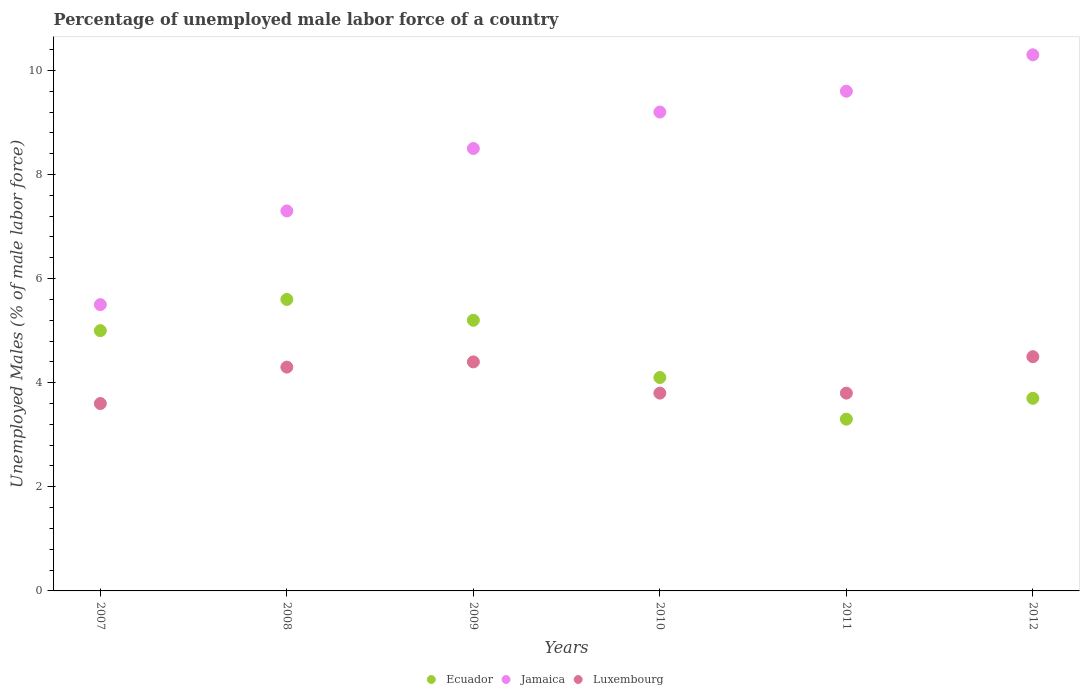Is the number of dotlines equal to the number of legend labels?
Ensure brevity in your answer.  Yes. Across all years, what is the maximum percentage of unemployed male labor force in Luxembourg?
Your answer should be compact. 4.5. Across all years, what is the minimum percentage of unemployed male labor force in Luxembourg?
Make the answer very short. 3.6. In which year was the percentage of unemployed male labor force in Ecuador maximum?
Your answer should be compact. 2008. In which year was the percentage of unemployed male labor force in Ecuador minimum?
Your answer should be compact. 2011. What is the total percentage of unemployed male labor force in Ecuador in the graph?
Your response must be concise. 26.9. What is the difference between the percentage of unemployed male labor force in Jamaica in 2010 and that in 2012?
Offer a terse response. -1.1. What is the difference between the percentage of unemployed male labor force in Jamaica in 2009 and the percentage of unemployed male labor force in Ecuador in 2012?
Make the answer very short. 4.8. What is the average percentage of unemployed male labor force in Ecuador per year?
Provide a succinct answer. 4.48. In the year 2007, what is the difference between the percentage of unemployed male labor force in Luxembourg and percentage of unemployed male labor force in Jamaica?
Your response must be concise. -1.9. What is the ratio of the percentage of unemployed male labor force in Luxembourg in 2007 to that in 2009?
Offer a terse response. 0.82. Is the percentage of unemployed male labor force in Jamaica in 2009 less than that in 2012?
Your response must be concise. Yes. Is the difference between the percentage of unemployed male labor force in Luxembourg in 2008 and 2009 greater than the difference between the percentage of unemployed male labor force in Jamaica in 2008 and 2009?
Your answer should be very brief. Yes. What is the difference between the highest and the second highest percentage of unemployed male labor force in Jamaica?
Make the answer very short. 0.7. What is the difference between the highest and the lowest percentage of unemployed male labor force in Jamaica?
Your answer should be compact. 4.8. Does the percentage of unemployed male labor force in Jamaica monotonically increase over the years?
Make the answer very short. Yes. Is the percentage of unemployed male labor force in Jamaica strictly greater than the percentage of unemployed male labor force in Luxembourg over the years?
Keep it short and to the point. Yes. Is the percentage of unemployed male labor force in Ecuador strictly less than the percentage of unemployed male labor force in Luxembourg over the years?
Your answer should be compact. No. How many dotlines are there?
Provide a short and direct response. 3. How many years are there in the graph?
Your response must be concise. 6. Are the values on the major ticks of Y-axis written in scientific E-notation?
Provide a short and direct response. No. Does the graph contain any zero values?
Your answer should be compact. No. What is the title of the graph?
Make the answer very short. Percentage of unemployed male labor force of a country. What is the label or title of the Y-axis?
Provide a short and direct response. Unemployed Males (% of male labor force). What is the Unemployed Males (% of male labor force) in Luxembourg in 2007?
Your response must be concise. 3.6. What is the Unemployed Males (% of male labor force) in Ecuador in 2008?
Offer a terse response. 5.6. What is the Unemployed Males (% of male labor force) of Jamaica in 2008?
Offer a terse response. 7.3. What is the Unemployed Males (% of male labor force) of Luxembourg in 2008?
Offer a very short reply. 4.3. What is the Unemployed Males (% of male labor force) in Ecuador in 2009?
Ensure brevity in your answer.  5.2. What is the Unemployed Males (% of male labor force) in Luxembourg in 2009?
Give a very brief answer. 4.4. What is the Unemployed Males (% of male labor force) of Ecuador in 2010?
Ensure brevity in your answer.  4.1. What is the Unemployed Males (% of male labor force) in Jamaica in 2010?
Ensure brevity in your answer.  9.2. What is the Unemployed Males (% of male labor force) of Luxembourg in 2010?
Offer a terse response. 3.8. What is the Unemployed Males (% of male labor force) of Ecuador in 2011?
Provide a short and direct response. 3.3. What is the Unemployed Males (% of male labor force) in Jamaica in 2011?
Offer a terse response. 9.6. What is the Unemployed Males (% of male labor force) of Luxembourg in 2011?
Your answer should be very brief. 3.8. What is the Unemployed Males (% of male labor force) in Ecuador in 2012?
Your answer should be compact. 3.7. What is the Unemployed Males (% of male labor force) in Jamaica in 2012?
Keep it short and to the point. 10.3. Across all years, what is the maximum Unemployed Males (% of male labor force) of Ecuador?
Make the answer very short. 5.6. Across all years, what is the maximum Unemployed Males (% of male labor force) of Jamaica?
Your answer should be very brief. 10.3. Across all years, what is the maximum Unemployed Males (% of male labor force) in Luxembourg?
Ensure brevity in your answer.  4.5. Across all years, what is the minimum Unemployed Males (% of male labor force) of Ecuador?
Offer a very short reply. 3.3. Across all years, what is the minimum Unemployed Males (% of male labor force) in Luxembourg?
Provide a short and direct response. 3.6. What is the total Unemployed Males (% of male labor force) of Ecuador in the graph?
Provide a succinct answer. 26.9. What is the total Unemployed Males (% of male labor force) in Jamaica in the graph?
Give a very brief answer. 50.4. What is the total Unemployed Males (% of male labor force) of Luxembourg in the graph?
Your answer should be very brief. 24.4. What is the difference between the Unemployed Males (% of male labor force) in Ecuador in 2007 and that in 2008?
Provide a short and direct response. -0.6. What is the difference between the Unemployed Males (% of male labor force) in Ecuador in 2007 and that in 2009?
Provide a succinct answer. -0.2. What is the difference between the Unemployed Males (% of male labor force) of Jamaica in 2007 and that in 2009?
Your response must be concise. -3. What is the difference between the Unemployed Males (% of male labor force) in Luxembourg in 2007 and that in 2010?
Offer a terse response. -0.2. What is the difference between the Unemployed Males (% of male labor force) of Ecuador in 2007 and that in 2011?
Offer a very short reply. 1.7. What is the difference between the Unemployed Males (% of male labor force) of Jamaica in 2007 and that in 2011?
Keep it short and to the point. -4.1. What is the difference between the Unemployed Males (% of male labor force) of Ecuador in 2007 and that in 2012?
Make the answer very short. 1.3. What is the difference between the Unemployed Males (% of male labor force) of Luxembourg in 2007 and that in 2012?
Make the answer very short. -0.9. What is the difference between the Unemployed Males (% of male labor force) of Ecuador in 2008 and that in 2009?
Offer a terse response. 0.4. What is the difference between the Unemployed Males (% of male labor force) of Jamaica in 2008 and that in 2010?
Offer a very short reply. -1.9. What is the difference between the Unemployed Males (% of male labor force) of Ecuador in 2008 and that in 2011?
Offer a very short reply. 2.3. What is the difference between the Unemployed Males (% of male labor force) in Jamaica in 2008 and that in 2011?
Your answer should be compact. -2.3. What is the difference between the Unemployed Males (% of male labor force) of Luxembourg in 2008 and that in 2011?
Provide a short and direct response. 0.5. What is the difference between the Unemployed Males (% of male labor force) in Jamaica in 2008 and that in 2012?
Your answer should be very brief. -3. What is the difference between the Unemployed Males (% of male labor force) of Luxembourg in 2009 and that in 2010?
Provide a succinct answer. 0.6. What is the difference between the Unemployed Males (% of male labor force) of Ecuador in 2009 and that in 2011?
Provide a succinct answer. 1.9. What is the difference between the Unemployed Males (% of male labor force) in Jamaica in 2009 and that in 2011?
Your answer should be very brief. -1.1. What is the difference between the Unemployed Males (% of male labor force) in Luxembourg in 2009 and that in 2011?
Provide a succinct answer. 0.6. What is the difference between the Unemployed Males (% of male labor force) of Ecuador in 2009 and that in 2012?
Your answer should be compact. 1.5. What is the difference between the Unemployed Males (% of male labor force) in Jamaica in 2009 and that in 2012?
Provide a short and direct response. -1.8. What is the difference between the Unemployed Males (% of male labor force) in Luxembourg in 2009 and that in 2012?
Keep it short and to the point. -0.1. What is the difference between the Unemployed Males (% of male labor force) of Jamaica in 2010 and that in 2011?
Ensure brevity in your answer.  -0.4. What is the difference between the Unemployed Males (% of male labor force) of Luxembourg in 2010 and that in 2011?
Provide a succinct answer. 0. What is the difference between the Unemployed Males (% of male labor force) of Ecuador in 2010 and that in 2012?
Offer a terse response. 0.4. What is the difference between the Unemployed Males (% of male labor force) of Luxembourg in 2010 and that in 2012?
Ensure brevity in your answer.  -0.7. What is the difference between the Unemployed Males (% of male labor force) in Jamaica in 2011 and that in 2012?
Keep it short and to the point. -0.7. What is the difference between the Unemployed Males (% of male labor force) of Jamaica in 2007 and the Unemployed Males (% of male labor force) of Luxembourg in 2009?
Provide a short and direct response. 1.1. What is the difference between the Unemployed Males (% of male labor force) in Ecuador in 2007 and the Unemployed Males (% of male labor force) in Luxembourg in 2010?
Your answer should be compact. 1.2. What is the difference between the Unemployed Males (% of male labor force) of Jamaica in 2007 and the Unemployed Males (% of male labor force) of Luxembourg in 2010?
Your response must be concise. 1.7. What is the difference between the Unemployed Males (% of male labor force) of Ecuador in 2007 and the Unemployed Males (% of male labor force) of Jamaica in 2011?
Provide a succinct answer. -4.6. What is the difference between the Unemployed Males (% of male labor force) in Ecuador in 2007 and the Unemployed Males (% of male labor force) in Jamaica in 2012?
Keep it short and to the point. -5.3. What is the difference between the Unemployed Males (% of male labor force) of Jamaica in 2007 and the Unemployed Males (% of male labor force) of Luxembourg in 2012?
Provide a short and direct response. 1. What is the difference between the Unemployed Males (% of male labor force) in Ecuador in 2008 and the Unemployed Males (% of male labor force) in Jamaica in 2009?
Provide a short and direct response. -2.9. What is the difference between the Unemployed Males (% of male labor force) in Ecuador in 2008 and the Unemployed Males (% of male labor force) in Jamaica in 2010?
Provide a short and direct response. -3.6. What is the difference between the Unemployed Males (% of male labor force) in Ecuador in 2008 and the Unemployed Males (% of male labor force) in Luxembourg in 2010?
Ensure brevity in your answer.  1.8. What is the difference between the Unemployed Males (% of male labor force) of Jamaica in 2008 and the Unemployed Males (% of male labor force) of Luxembourg in 2010?
Provide a succinct answer. 3.5. What is the difference between the Unemployed Males (% of male labor force) of Jamaica in 2008 and the Unemployed Males (% of male labor force) of Luxembourg in 2011?
Provide a succinct answer. 3.5. What is the difference between the Unemployed Males (% of male labor force) in Ecuador in 2008 and the Unemployed Males (% of male labor force) in Jamaica in 2012?
Keep it short and to the point. -4.7. What is the difference between the Unemployed Males (% of male labor force) in Jamaica in 2008 and the Unemployed Males (% of male labor force) in Luxembourg in 2012?
Keep it short and to the point. 2.8. What is the difference between the Unemployed Males (% of male labor force) in Ecuador in 2009 and the Unemployed Males (% of male labor force) in Jamaica in 2010?
Offer a very short reply. -4. What is the difference between the Unemployed Males (% of male labor force) of Ecuador in 2009 and the Unemployed Males (% of male labor force) of Luxembourg in 2010?
Your answer should be compact. 1.4. What is the difference between the Unemployed Males (% of male labor force) of Ecuador in 2009 and the Unemployed Males (% of male labor force) of Luxembourg in 2011?
Your answer should be compact. 1.4. What is the difference between the Unemployed Males (% of male labor force) of Jamaica in 2009 and the Unemployed Males (% of male labor force) of Luxembourg in 2011?
Make the answer very short. 4.7. What is the difference between the Unemployed Males (% of male labor force) in Ecuador in 2009 and the Unemployed Males (% of male labor force) in Jamaica in 2012?
Provide a succinct answer. -5.1. What is the difference between the Unemployed Males (% of male labor force) of Ecuador in 2009 and the Unemployed Males (% of male labor force) of Luxembourg in 2012?
Give a very brief answer. 0.7. What is the difference between the Unemployed Males (% of male labor force) in Ecuador in 2010 and the Unemployed Males (% of male labor force) in Luxembourg in 2011?
Offer a very short reply. 0.3. What is the difference between the Unemployed Males (% of male labor force) of Jamaica in 2010 and the Unemployed Males (% of male labor force) of Luxembourg in 2011?
Provide a succinct answer. 5.4. What is the difference between the Unemployed Males (% of male labor force) in Ecuador in 2010 and the Unemployed Males (% of male labor force) in Luxembourg in 2012?
Your answer should be very brief. -0.4. What is the difference between the Unemployed Males (% of male labor force) of Jamaica in 2010 and the Unemployed Males (% of male labor force) of Luxembourg in 2012?
Ensure brevity in your answer.  4.7. What is the difference between the Unemployed Males (% of male labor force) of Ecuador in 2011 and the Unemployed Males (% of male labor force) of Jamaica in 2012?
Provide a short and direct response. -7. What is the difference between the Unemployed Males (% of male labor force) of Ecuador in 2011 and the Unemployed Males (% of male labor force) of Luxembourg in 2012?
Make the answer very short. -1.2. What is the difference between the Unemployed Males (% of male labor force) in Jamaica in 2011 and the Unemployed Males (% of male labor force) in Luxembourg in 2012?
Your answer should be compact. 5.1. What is the average Unemployed Males (% of male labor force) of Ecuador per year?
Your answer should be very brief. 4.48. What is the average Unemployed Males (% of male labor force) of Luxembourg per year?
Your response must be concise. 4.07. In the year 2007, what is the difference between the Unemployed Males (% of male labor force) in Jamaica and Unemployed Males (% of male labor force) in Luxembourg?
Offer a very short reply. 1.9. In the year 2008, what is the difference between the Unemployed Males (% of male labor force) in Ecuador and Unemployed Males (% of male labor force) in Luxembourg?
Offer a terse response. 1.3. In the year 2009, what is the difference between the Unemployed Males (% of male labor force) of Ecuador and Unemployed Males (% of male labor force) of Jamaica?
Your answer should be very brief. -3.3. In the year 2010, what is the difference between the Unemployed Males (% of male labor force) in Ecuador and Unemployed Males (% of male labor force) in Jamaica?
Your answer should be very brief. -5.1. In the year 2010, what is the difference between the Unemployed Males (% of male labor force) in Jamaica and Unemployed Males (% of male labor force) in Luxembourg?
Provide a short and direct response. 5.4. In the year 2011, what is the difference between the Unemployed Males (% of male labor force) of Ecuador and Unemployed Males (% of male labor force) of Jamaica?
Provide a short and direct response. -6.3. In the year 2011, what is the difference between the Unemployed Males (% of male labor force) in Jamaica and Unemployed Males (% of male labor force) in Luxembourg?
Offer a very short reply. 5.8. In the year 2012, what is the difference between the Unemployed Males (% of male labor force) of Ecuador and Unemployed Males (% of male labor force) of Jamaica?
Make the answer very short. -6.6. In the year 2012, what is the difference between the Unemployed Males (% of male labor force) in Ecuador and Unemployed Males (% of male labor force) in Luxembourg?
Your answer should be compact. -0.8. What is the ratio of the Unemployed Males (% of male labor force) of Ecuador in 2007 to that in 2008?
Provide a succinct answer. 0.89. What is the ratio of the Unemployed Males (% of male labor force) in Jamaica in 2007 to that in 2008?
Make the answer very short. 0.75. What is the ratio of the Unemployed Males (% of male labor force) of Luxembourg in 2007 to that in 2008?
Ensure brevity in your answer.  0.84. What is the ratio of the Unemployed Males (% of male labor force) of Ecuador in 2007 to that in 2009?
Offer a very short reply. 0.96. What is the ratio of the Unemployed Males (% of male labor force) in Jamaica in 2007 to that in 2009?
Provide a succinct answer. 0.65. What is the ratio of the Unemployed Males (% of male labor force) of Luxembourg in 2007 to that in 2009?
Ensure brevity in your answer.  0.82. What is the ratio of the Unemployed Males (% of male labor force) of Ecuador in 2007 to that in 2010?
Provide a succinct answer. 1.22. What is the ratio of the Unemployed Males (% of male labor force) in Jamaica in 2007 to that in 2010?
Provide a short and direct response. 0.6. What is the ratio of the Unemployed Males (% of male labor force) of Ecuador in 2007 to that in 2011?
Provide a short and direct response. 1.52. What is the ratio of the Unemployed Males (% of male labor force) of Jamaica in 2007 to that in 2011?
Give a very brief answer. 0.57. What is the ratio of the Unemployed Males (% of male labor force) in Ecuador in 2007 to that in 2012?
Your response must be concise. 1.35. What is the ratio of the Unemployed Males (% of male labor force) in Jamaica in 2007 to that in 2012?
Your answer should be very brief. 0.53. What is the ratio of the Unemployed Males (% of male labor force) in Luxembourg in 2007 to that in 2012?
Keep it short and to the point. 0.8. What is the ratio of the Unemployed Males (% of male labor force) in Ecuador in 2008 to that in 2009?
Make the answer very short. 1.08. What is the ratio of the Unemployed Males (% of male labor force) in Jamaica in 2008 to that in 2009?
Provide a succinct answer. 0.86. What is the ratio of the Unemployed Males (% of male labor force) of Luxembourg in 2008 to that in 2009?
Make the answer very short. 0.98. What is the ratio of the Unemployed Males (% of male labor force) in Ecuador in 2008 to that in 2010?
Make the answer very short. 1.37. What is the ratio of the Unemployed Males (% of male labor force) in Jamaica in 2008 to that in 2010?
Offer a terse response. 0.79. What is the ratio of the Unemployed Males (% of male labor force) in Luxembourg in 2008 to that in 2010?
Keep it short and to the point. 1.13. What is the ratio of the Unemployed Males (% of male labor force) of Ecuador in 2008 to that in 2011?
Your answer should be compact. 1.7. What is the ratio of the Unemployed Males (% of male labor force) of Jamaica in 2008 to that in 2011?
Keep it short and to the point. 0.76. What is the ratio of the Unemployed Males (% of male labor force) of Luxembourg in 2008 to that in 2011?
Make the answer very short. 1.13. What is the ratio of the Unemployed Males (% of male labor force) in Ecuador in 2008 to that in 2012?
Provide a short and direct response. 1.51. What is the ratio of the Unemployed Males (% of male labor force) of Jamaica in 2008 to that in 2012?
Offer a terse response. 0.71. What is the ratio of the Unemployed Males (% of male labor force) in Luxembourg in 2008 to that in 2012?
Offer a terse response. 0.96. What is the ratio of the Unemployed Males (% of male labor force) of Ecuador in 2009 to that in 2010?
Provide a succinct answer. 1.27. What is the ratio of the Unemployed Males (% of male labor force) in Jamaica in 2009 to that in 2010?
Ensure brevity in your answer.  0.92. What is the ratio of the Unemployed Males (% of male labor force) of Luxembourg in 2009 to that in 2010?
Your answer should be very brief. 1.16. What is the ratio of the Unemployed Males (% of male labor force) of Ecuador in 2009 to that in 2011?
Offer a very short reply. 1.58. What is the ratio of the Unemployed Males (% of male labor force) in Jamaica in 2009 to that in 2011?
Your answer should be compact. 0.89. What is the ratio of the Unemployed Males (% of male labor force) in Luxembourg in 2009 to that in 2011?
Your response must be concise. 1.16. What is the ratio of the Unemployed Males (% of male labor force) in Ecuador in 2009 to that in 2012?
Your answer should be very brief. 1.41. What is the ratio of the Unemployed Males (% of male labor force) of Jamaica in 2009 to that in 2012?
Give a very brief answer. 0.83. What is the ratio of the Unemployed Males (% of male labor force) in Luxembourg in 2009 to that in 2012?
Your answer should be very brief. 0.98. What is the ratio of the Unemployed Males (% of male labor force) in Ecuador in 2010 to that in 2011?
Make the answer very short. 1.24. What is the ratio of the Unemployed Males (% of male labor force) in Jamaica in 2010 to that in 2011?
Provide a succinct answer. 0.96. What is the ratio of the Unemployed Males (% of male labor force) of Luxembourg in 2010 to that in 2011?
Your response must be concise. 1. What is the ratio of the Unemployed Males (% of male labor force) of Ecuador in 2010 to that in 2012?
Keep it short and to the point. 1.11. What is the ratio of the Unemployed Males (% of male labor force) of Jamaica in 2010 to that in 2012?
Provide a succinct answer. 0.89. What is the ratio of the Unemployed Males (% of male labor force) in Luxembourg in 2010 to that in 2012?
Make the answer very short. 0.84. What is the ratio of the Unemployed Males (% of male labor force) in Ecuador in 2011 to that in 2012?
Your answer should be very brief. 0.89. What is the ratio of the Unemployed Males (% of male labor force) of Jamaica in 2011 to that in 2012?
Provide a succinct answer. 0.93. What is the ratio of the Unemployed Males (% of male labor force) in Luxembourg in 2011 to that in 2012?
Your answer should be compact. 0.84. What is the difference between the highest and the second highest Unemployed Males (% of male labor force) in Jamaica?
Make the answer very short. 0.7. What is the difference between the highest and the lowest Unemployed Males (% of male labor force) in Ecuador?
Give a very brief answer. 2.3. 